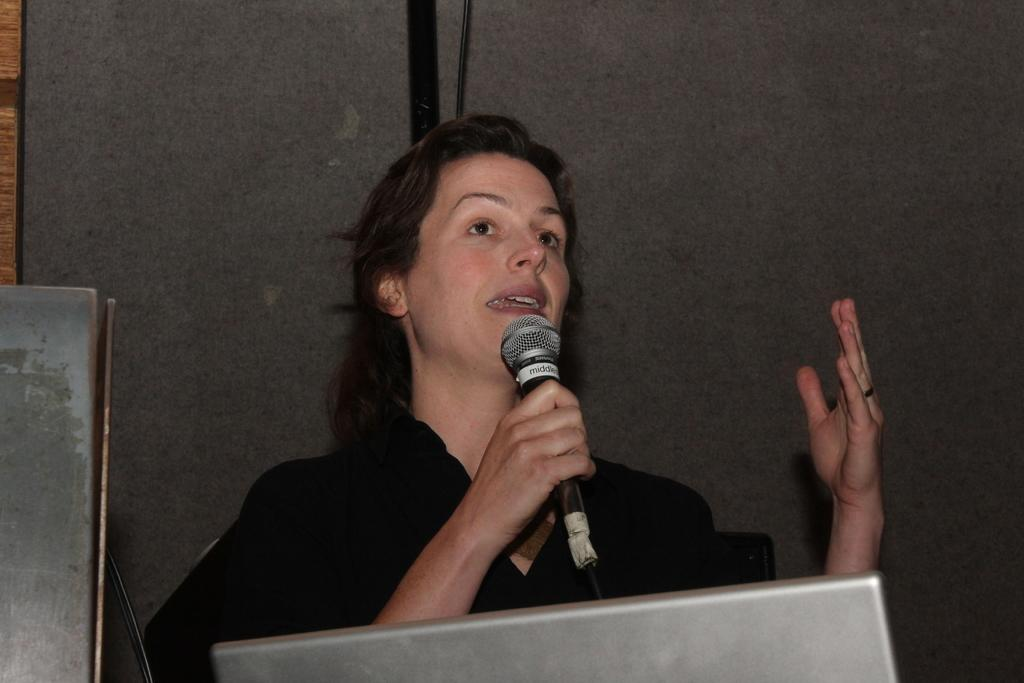Who is the main subject in the image? There is a woman in the image. What is the woman holding in the image? The woman is holding a microphone. Can you describe any other objects visible in the image? There are objects visible in the image, but their specific details are not mentioned in the provided facts. What type of authority does the woman have over the sponge in the image? There is no sponge present in the image, so the woman does not have any authority over a sponge. 